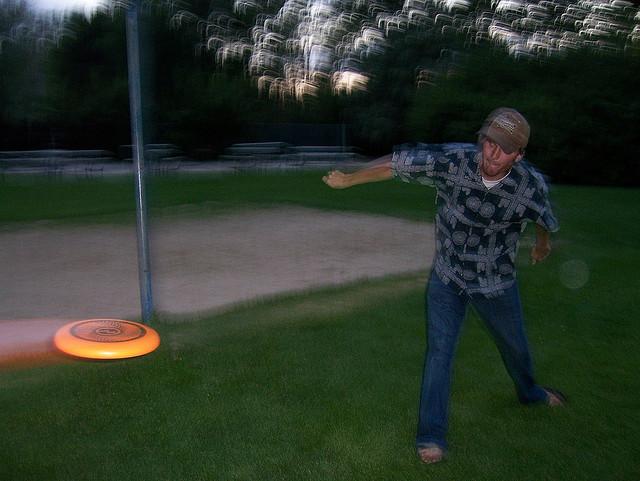What sport is the man playing?
Be succinct. Frisbee. Does one need lots of space to play this sport?
Keep it brief. Yes. How fast can a frisbee fly?
Concise answer only. Fast. What pattern is the shirt?
Short answer required. Hawaiian. What is the man doing?
Give a very brief answer. Throwing. What pattern is on the man's shirt?
Quick response, please. Plaid. What is the man throwing?
Be succinct. Frisbee. 